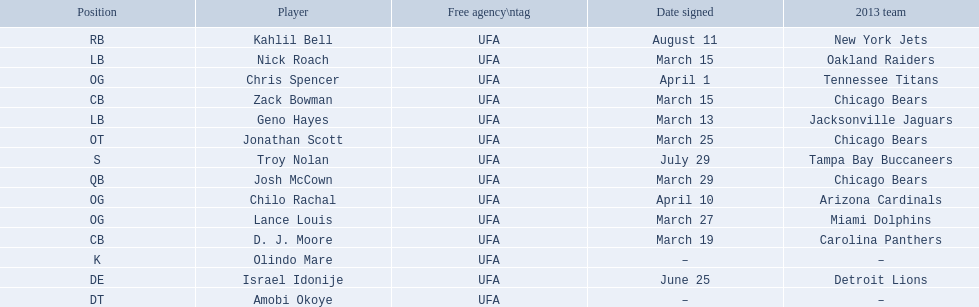What are all the dates signed? March 29, August 11, March 27, April 1, April 10, March 25, June 25, March 13, March 15, March 15, March 19, July 29. Which of these are duplicates? March 15, March 15. Who has the same one as nick roach? Zack Bowman. 